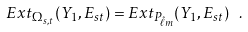<formula> <loc_0><loc_0><loc_500><loc_500>E x t _ { \Omega _ { s , t } } ( Y _ { 1 } , E _ { s t } ) = E x t _ { P _ { \hat { \ell } m } } ( Y _ { 1 } , E _ { s t } ) \ .</formula> 